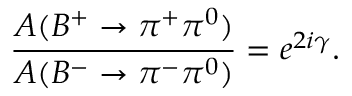<formula> <loc_0><loc_0><loc_500><loc_500>\frac { A ( B ^ { + } \to \pi ^ { + } \pi ^ { 0 } ) } { A ( B ^ { - } \to \pi ^ { - } \pi ^ { 0 } ) } = e ^ { 2 i \gamma } .</formula> 